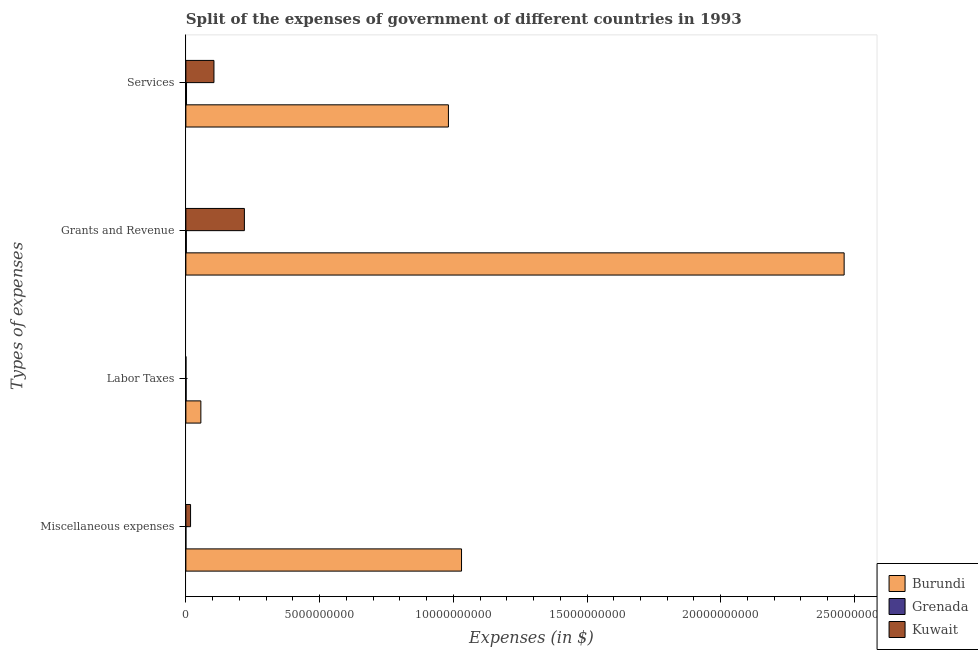Are the number of bars per tick equal to the number of legend labels?
Provide a short and direct response. Yes. Are the number of bars on each tick of the Y-axis equal?
Make the answer very short. Yes. What is the label of the 3rd group of bars from the top?
Ensure brevity in your answer.  Labor Taxes. What is the amount spent on labor taxes in Grenada?
Offer a terse response. 8.93e+06. Across all countries, what is the maximum amount spent on labor taxes?
Your answer should be compact. 5.60e+08. Across all countries, what is the minimum amount spent on miscellaneous expenses?
Your answer should be compact. 3.30e+05. In which country was the amount spent on services maximum?
Provide a succinct answer. Burundi. In which country was the amount spent on grants and revenue minimum?
Provide a short and direct response. Grenada. What is the total amount spent on labor taxes in the graph?
Ensure brevity in your answer.  5.71e+08. What is the difference between the amount spent on miscellaneous expenses in Burundi and that in Kuwait?
Provide a short and direct response. 1.01e+1. What is the difference between the amount spent on labor taxes in Burundi and the amount spent on services in Grenada?
Offer a very short reply. 5.36e+08. What is the average amount spent on miscellaneous expenses per country?
Ensure brevity in your answer.  3.49e+09. What is the difference between the amount spent on miscellaneous expenses and amount spent on services in Kuwait?
Give a very brief answer. -8.75e+08. What is the ratio of the amount spent on miscellaneous expenses in Grenada to that in Burundi?
Make the answer very short. 3.20139697322468e-5. What is the difference between the highest and the second highest amount spent on grants and revenue?
Offer a very short reply. 2.24e+1. What is the difference between the highest and the lowest amount spent on miscellaneous expenses?
Provide a succinct answer. 1.03e+1. What does the 3rd bar from the top in Grants and Revenue represents?
Provide a short and direct response. Burundi. What does the 2nd bar from the bottom in Services represents?
Your response must be concise. Grenada. How many countries are there in the graph?
Give a very brief answer. 3. Are the values on the major ticks of X-axis written in scientific E-notation?
Your answer should be compact. No. Does the graph contain any zero values?
Ensure brevity in your answer.  No. Does the graph contain grids?
Ensure brevity in your answer.  No. What is the title of the graph?
Offer a terse response. Split of the expenses of government of different countries in 1993. What is the label or title of the X-axis?
Your answer should be very brief. Expenses (in $). What is the label or title of the Y-axis?
Give a very brief answer. Types of expenses. What is the Expenses (in $) of Burundi in Miscellaneous expenses?
Keep it short and to the point. 1.03e+1. What is the Expenses (in $) of Kuwait in Miscellaneous expenses?
Ensure brevity in your answer.  1.75e+08. What is the Expenses (in $) in Burundi in Labor Taxes?
Offer a very short reply. 5.60e+08. What is the Expenses (in $) in Grenada in Labor Taxes?
Your answer should be compact. 8.93e+06. What is the Expenses (in $) in Burundi in Grants and Revenue?
Your response must be concise. 2.46e+1. What is the Expenses (in $) in Grenada in Grants and Revenue?
Your answer should be very brief. 1.63e+07. What is the Expenses (in $) of Kuwait in Grants and Revenue?
Provide a succinct answer. 2.19e+09. What is the Expenses (in $) of Burundi in Services?
Provide a succinct answer. 9.82e+09. What is the Expenses (in $) in Grenada in Services?
Give a very brief answer. 2.40e+07. What is the Expenses (in $) of Kuwait in Services?
Your response must be concise. 1.05e+09. Across all Types of expenses, what is the maximum Expenses (in $) of Burundi?
Provide a succinct answer. 2.46e+1. Across all Types of expenses, what is the maximum Expenses (in $) in Grenada?
Your answer should be very brief. 2.40e+07. Across all Types of expenses, what is the maximum Expenses (in $) in Kuwait?
Provide a short and direct response. 2.19e+09. Across all Types of expenses, what is the minimum Expenses (in $) of Burundi?
Provide a succinct answer. 5.60e+08. What is the total Expenses (in $) in Burundi in the graph?
Provide a short and direct response. 4.53e+1. What is the total Expenses (in $) of Grenada in the graph?
Offer a terse response. 4.96e+07. What is the total Expenses (in $) of Kuwait in the graph?
Provide a succinct answer. 3.42e+09. What is the difference between the Expenses (in $) in Burundi in Miscellaneous expenses and that in Labor Taxes?
Offer a terse response. 9.75e+09. What is the difference between the Expenses (in $) in Grenada in Miscellaneous expenses and that in Labor Taxes?
Your answer should be compact. -8.60e+06. What is the difference between the Expenses (in $) in Kuwait in Miscellaneous expenses and that in Labor Taxes?
Provide a succinct answer. 1.73e+08. What is the difference between the Expenses (in $) of Burundi in Miscellaneous expenses and that in Grants and Revenue?
Offer a very short reply. -1.43e+1. What is the difference between the Expenses (in $) of Grenada in Miscellaneous expenses and that in Grants and Revenue?
Provide a succinct answer. -1.60e+07. What is the difference between the Expenses (in $) in Kuwait in Miscellaneous expenses and that in Grants and Revenue?
Give a very brief answer. -2.01e+09. What is the difference between the Expenses (in $) of Burundi in Miscellaneous expenses and that in Services?
Keep it short and to the point. 4.90e+08. What is the difference between the Expenses (in $) in Grenada in Miscellaneous expenses and that in Services?
Your answer should be very brief. -2.36e+07. What is the difference between the Expenses (in $) in Kuwait in Miscellaneous expenses and that in Services?
Keep it short and to the point. -8.75e+08. What is the difference between the Expenses (in $) in Burundi in Labor Taxes and that in Grants and Revenue?
Provide a succinct answer. -2.41e+1. What is the difference between the Expenses (in $) of Grenada in Labor Taxes and that in Grants and Revenue?
Ensure brevity in your answer.  -7.40e+06. What is the difference between the Expenses (in $) of Kuwait in Labor Taxes and that in Grants and Revenue?
Ensure brevity in your answer.  -2.19e+09. What is the difference between the Expenses (in $) of Burundi in Labor Taxes and that in Services?
Your response must be concise. -9.26e+09. What is the difference between the Expenses (in $) of Grenada in Labor Taxes and that in Services?
Offer a terse response. -1.50e+07. What is the difference between the Expenses (in $) of Kuwait in Labor Taxes and that in Services?
Make the answer very short. -1.05e+09. What is the difference between the Expenses (in $) of Burundi in Grants and Revenue and that in Services?
Provide a short and direct response. 1.48e+1. What is the difference between the Expenses (in $) of Grenada in Grants and Revenue and that in Services?
Give a very brief answer. -7.65e+06. What is the difference between the Expenses (in $) in Kuwait in Grants and Revenue and that in Services?
Give a very brief answer. 1.14e+09. What is the difference between the Expenses (in $) in Burundi in Miscellaneous expenses and the Expenses (in $) in Grenada in Labor Taxes?
Your answer should be very brief. 1.03e+1. What is the difference between the Expenses (in $) in Burundi in Miscellaneous expenses and the Expenses (in $) in Kuwait in Labor Taxes?
Offer a very short reply. 1.03e+1. What is the difference between the Expenses (in $) of Grenada in Miscellaneous expenses and the Expenses (in $) of Kuwait in Labor Taxes?
Your answer should be compact. -1.67e+06. What is the difference between the Expenses (in $) of Burundi in Miscellaneous expenses and the Expenses (in $) of Grenada in Grants and Revenue?
Offer a terse response. 1.03e+1. What is the difference between the Expenses (in $) in Burundi in Miscellaneous expenses and the Expenses (in $) in Kuwait in Grants and Revenue?
Make the answer very short. 8.12e+09. What is the difference between the Expenses (in $) of Grenada in Miscellaneous expenses and the Expenses (in $) of Kuwait in Grants and Revenue?
Keep it short and to the point. -2.19e+09. What is the difference between the Expenses (in $) in Burundi in Miscellaneous expenses and the Expenses (in $) in Grenada in Services?
Provide a short and direct response. 1.03e+1. What is the difference between the Expenses (in $) in Burundi in Miscellaneous expenses and the Expenses (in $) in Kuwait in Services?
Make the answer very short. 9.26e+09. What is the difference between the Expenses (in $) of Grenada in Miscellaneous expenses and the Expenses (in $) of Kuwait in Services?
Your answer should be compact. -1.05e+09. What is the difference between the Expenses (in $) of Burundi in Labor Taxes and the Expenses (in $) of Grenada in Grants and Revenue?
Your response must be concise. 5.44e+08. What is the difference between the Expenses (in $) in Burundi in Labor Taxes and the Expenses (in $) in Kuwait in Grants and Revenue?
Ensure brevity in your answer.  -1.63e+09. What is the difference between the Expenses (in $) of Grenada in Labor Taxes and the Expenses (in $) of Kuwait in Grants and Revenue?
Provide a succinct answer. -2.18e+09. What is the difference between the Expenses (in $) in Burundi in Labor Taxes and the Expenses (in $) in Grenada in Services?
Keep it short and to the point. 5.36e+08. What is the difference between the Expenses (in $) of Burundi in Labor Taxes and the Expenses (in $) of Kuwait in Services?
Ensure brevity in your answer.  -4.90e+08. What is the difference between the Expenses (in $) of Grenada in Labor Taxes and the Expenses (in $) of Kuwait in Services?
Make the answer very short. -1.04e+09. What is the difference between the Expenses (in $) of Burundi in Grants and Revenue and the Expenses (in $) of Grenada in Services?
Ensure brevity in your answer.  2.46e+1. What is the difference between the Expenses (in $) of Burundi in Grants and Revenue and the Expenses (in $) of Kuwait in Services?
Provide a short and direct response. 2.36e+1. What is the difference between the Expenses (in $) of Grenada in Grants and Revenue and the Expenses (in $) of Kuwait in Services?
Your answer should be very brief. -1.03e+09. What is the average Expenses (in $) in Burundi per Types of expenses?
Provide a succinct answer. 1.13e+1. What is the average Expenses (in $) in Grenada per Types of expenses?
Your answer should be compact. 1.24e+07. What is the average Expenses (in $) of Kuwait per Types of expenses?
Your response must be concise. 8.54e+08. What is the difference between the Expenses (in $) of Burundi and Expenses (in $) of Grenada in Miscellaneous expenses?
Your answer should be compact. 1.03e+1. What is the difference between the Expenses (in $) of Burundi and Expenses (in $) of Kuwait in Miscellaneous expenses?
Provide a succinct answer. 1.01e+1. What is the difference between the Expenses (in $) of Grenada and Expenses (in $) of Kuwait in Miscellaneous expenses?
Give a very brief answer. -1.75e+08. What is the difference between the Expenses (in $) of Burundi and Expenses (in $) of Grenada in Labor Taxes?
Your answer should be compact. 5.51e+08. What is the difference between the Expenses (in $) in Burundi and Expenses (in $) in Kuwait in Labor Taxes?
Your answer should be very brief. 5.58e+08. What is the difference between the Expenses (in $) of Grenada and Expenses (in $) of Kuwait in Labor Taxes?
Keep it short and to the point. 6.93e+06. What is the difference between the Expenses (in $) in Burundi and Expenses (in $) in Grenada in Grants and Revenue?
Provide a succinct answer. 2.46e+1. What is the difference between the Expenses (in $) in Burundi and Expenses (in $) in Kuwait in Grants and Revenue?
Make the answer very short. 2.24e+1. What is the difference between the Expenses (in $) in Grenada and Expenses (in $) in Kuwait in Grants and Revenue?
Your answer should be compact. -2.17e+09. What is the difference between the Expenses (in $) of Burundi and Expenses (in $) of Grenada in Services?
Offer a terse response. 9.79e+09. What is the difference between the Expenses (in $) in Burundi and Expenses (in $) in Kuwait in Services?
Offer a terse response. 8.77e+09. What is the difference between the Expenses (in $) in Grenada and Expenses (in $) in Kuwait in Services?
Your answer should be very brief. -1.03e+09. What is the ratio of the Expenses (in $) of Burundi in Miscellaneous expenses to that in Labor Taxes?
Offer a terse response. 18.41. What is the ratio of the Expenses (in $) in Grenada in Miscellaneous expenses to that in Labor Taxes?
Offer a very short reply. 0.04. What is the ratio of the Expenses (in $) of Kuwait in Miscellaneous expenses to that in Labor Taxes?
Your answer should be compact. 87.5. What is the ratio of the Expenses (in $) in Burundi in Miscellaneous expenses to that in Grants and Revenue?
Provide a short and direct response. 0.42. What is the ratio of the Expenses (in $) of Grenada in Miscellaneous expenses to that in Grants and Revenue?
Ensure brevity in your answer.  0.02. What is the ratio of the Expenses (in $) in Burundi in Miscellaneous expenses to that in Services?
Make the answer very short. 1.05. What is the ratio of the Expenses (in $) in Grenada in Miscellaneous expenses to that in Services?
Provide a succinct answer. 0.01. What is the ratio of the Expenses (in $) in Burundi in Labor Taxes to that in Grants and Revenue?
Give a very brief answer. 0.02. What is the ratio of the Expenses (in $) in Grenada in Labor Taxes to that in Grants and Revenue?
Provide a succinct answer. 0.55. What is the ratio of the Expenses (in $) of Kuwait in Labor Taxes to that in Grants and Revenue?
Keep it short and to the point. 0. What is the ratio of the Expenses (in $) of Burundi in Labor Taxes to that in Services?
Offer a very short reply. 0.06. What is the ratio of the Expenses (in $) in Grenada in Labor Taxes to that in Services?
Make the answer very short. 0.37. What is the ratio of the Expenses (in $) of Kuwait in Labor Taxes to that in Services?
Provide a short and direct response. 0. What is the ratio of the Expenses (in $) of Burundi in Grants and Revenue to that in Services?
Your answer should be compact. 2.51. What is the ratio of the Expenses (in $) of Grenada in Grants and Revenue to that in Services?
Ensure brevity in your answer.  0.68. What is the ratio of the Expenses (in $) in Kuwait in Grants and Revenue to that in Services?
Keep it short and to the point. 2.08. What is the difference between the highest and the second highest Expenses (in $) of Burundi?
Make the answer very short. 1.43e+1. What is the difference between the highest and the second highest Expenses (in $) in Grenada?
Your answer should be compact. 7.65e+06. What is the difference between the highest and the second highest Expenses (in $) of Kuwait?
Your response must be concise. 1.14e+09. What is the difference between the highest and the lowest Expenses (in $) in Burundi?
Keep it short and to the point. 2.41e+1. What is the difference between the highest and the lowest Expenses (in $) of Grenada?
Provide a succinct answer. 2.36e+07. What is the difference between the highest and the lowest Expenses (in $) of Kuwait?
Ensure brevity in your answer.  2.19e+09. 